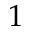Convert formula to latex. <formula><loc_0><loc_0><loc_500><loc_500>1</formula> 